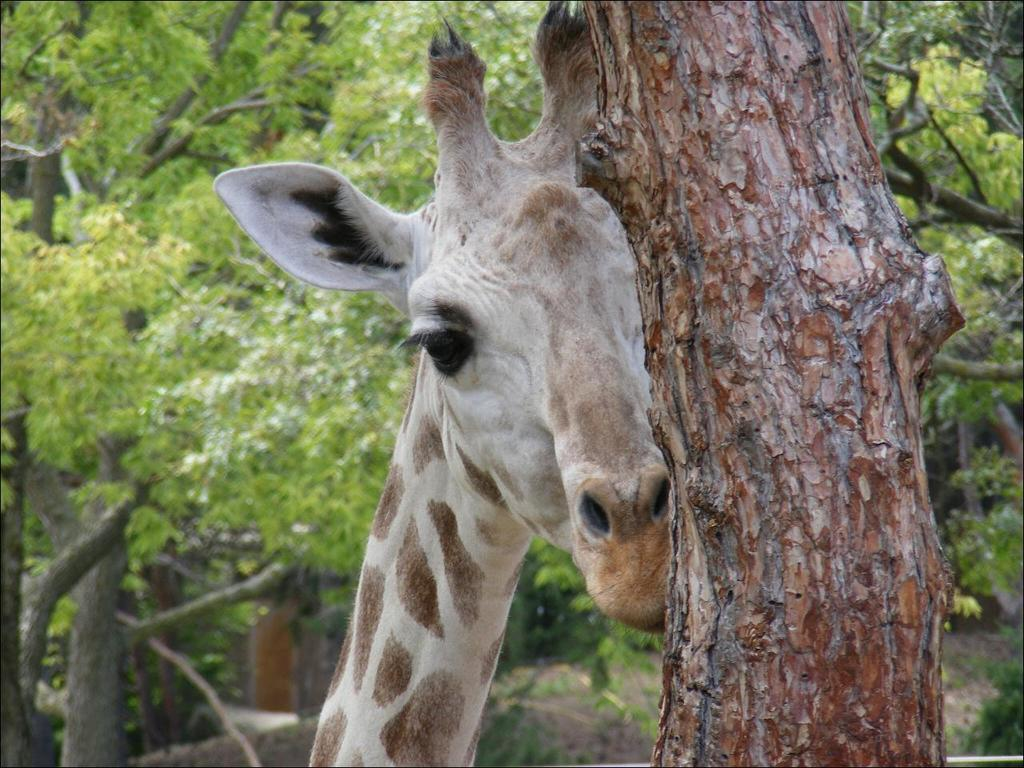What animal is present in the image? There is a giraffe in the image. What can be seen on the right side of the image? There is a tree on the right side of the image. What is visible in the background of the image? There are many trees visible in the background of the image. What type of spoon is being used by the giraffe in the image? There is no spoon present in the image, as it features a giraffe and trees. What kind of party is happening in the image? There is no party depicted in the image; it shows a giraffe and trees. 